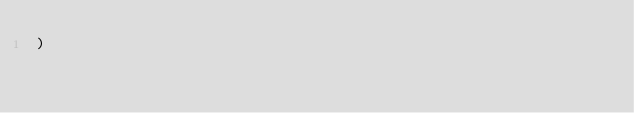Convert code to text. <code><loc_0><loc_0><loc_500><loc_500><_SQL_>)</code> 